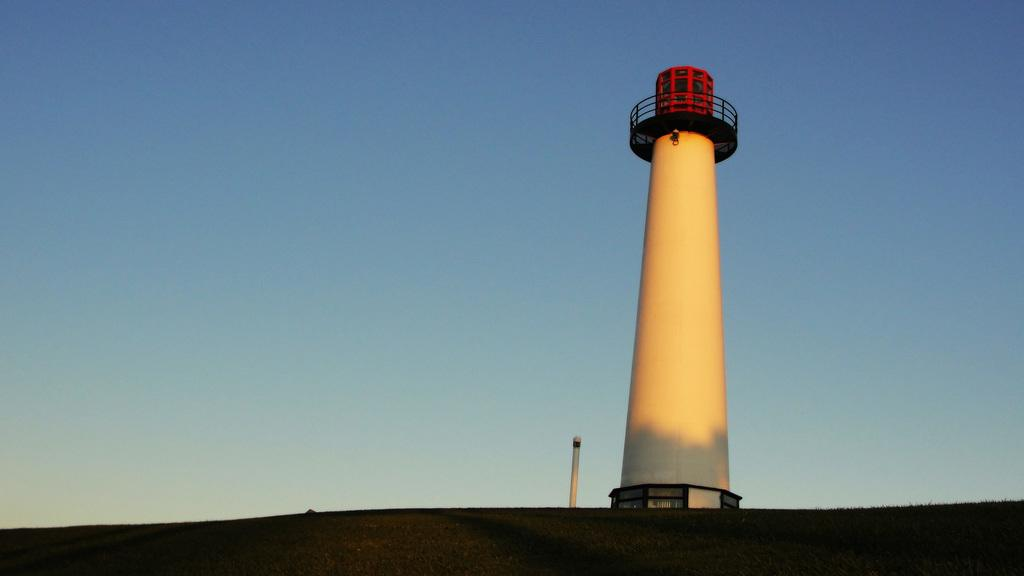What is the main structure in the image? There is a lighthouse in the image. What can be seen in the background of the image? The sky is visible in the background of the image. What type of grain is being harvested by the boy in the image? There is no boy or grain present in the image; it only features a lighthouse and the sky. 